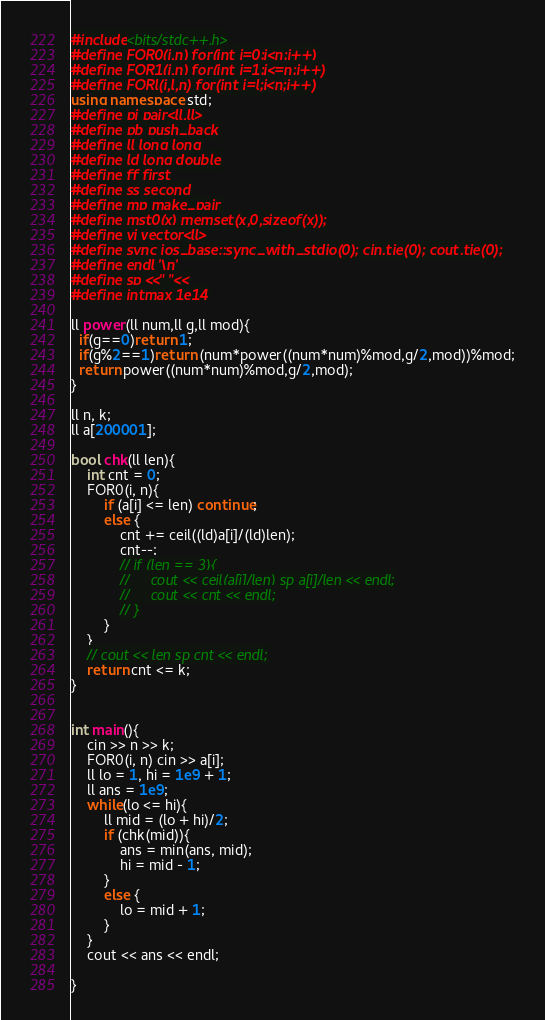Convert code to text. <code><loc_0><loc_0><loc_500><loc_500><_C++_>#include<bits/stdc++.h>
#define FOR0(i,n) for(int i=0;i<n;i++)
#define FOR1(i,n) for(int i=1;i<=n;i++)
#define FORl(i,l,n) for(int i=l;i<n;i++)
using namespace std;
#define pi pair<ll,ll>
#define pb push_back
#define ll long long
#define ld long double
#define ff first
#define ss second
#define mp make_pair
#define mst0(x) memset(x,0,sizeof(x));
#define vi vector<ll>
#define sync ios_base::sync_with_stdio(0); cin.tie(0); cout.tie(0);
#define endl '\n'
#define sp <<" "<<
#define intmax 1e14

ll power(ll num,ll g,ll mod){
  if(g==0)return 1;
  if(g%2==1)return (num*power((num*num)%mod,g/2,mod))%mod;
  return power((num*num)%mod,g/2,mod);
}

ll n, k;
ll a[200001];

bool chk(ll len){
    int cnt = 0;
    FOR0(i, n){
        if (a[i] <= len) continue;
        else {
            cnt += ceil((ld)a[i]/(ld)len);
            cnt--;
            // if (len == 3){
            //     cout << ceil(a[i]/len) sp a[i]/len << endl;
            //     cout << cnt << endl;
            // }
        }
    }
    // cout << len sp cnt << endl;
    return cnt <= k;
}


int main(){
    cin >> n >> k;
    FOR0(i, n) cin >> a[i];
    ll lo = 1, hi = 1e9 + 1;
    ll ans = 1e9;
    while(lo <= hi){
        ll mid = (lo + hi)/2;
        if (chk(mid)){
            ans = min(ans, mid);
            hi = mid - 1;
        }
        else {
            lo = mid + 1;
        }
    }
    cout << ans << endl;

}</code> 